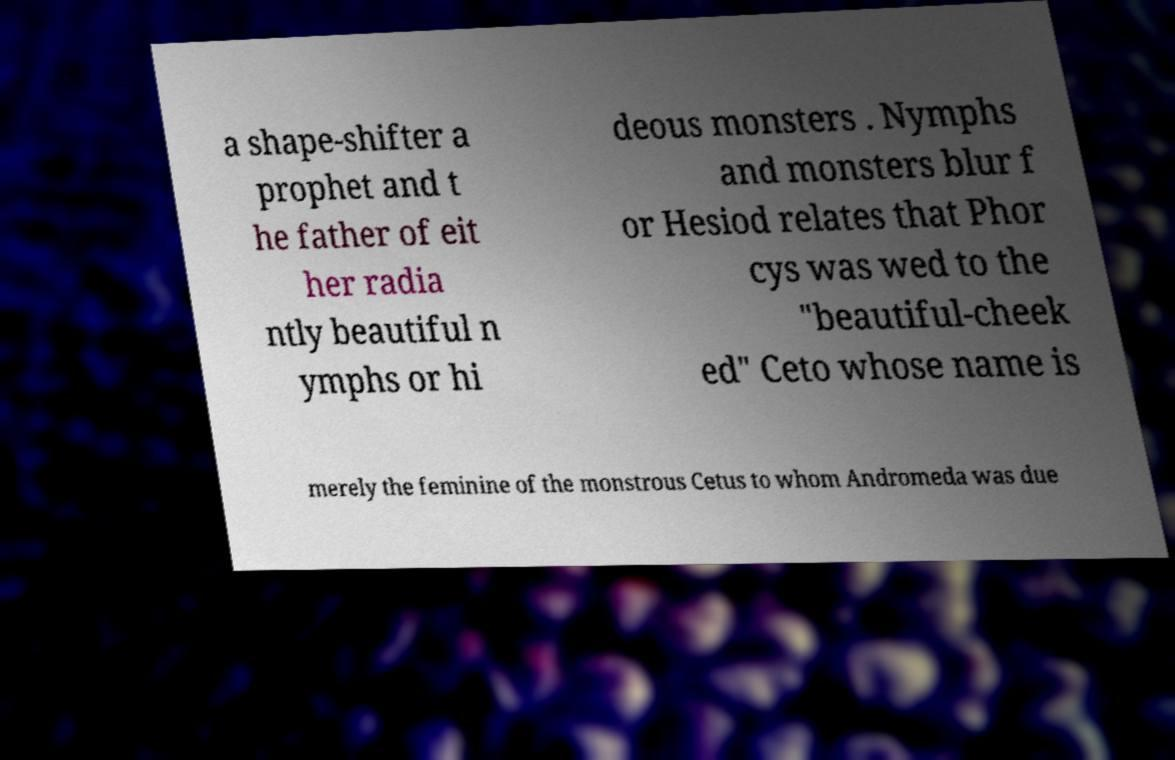I need the written content from this picture converted into text. Can you do that? a shape-shifter a prophet and t he father of eit her radia ntly beautiful n ymphs or hi deous monsters . Nymphs and monsters blur f or Hesiod relates that Phor cys was wed to the "beautiful-cheek ed" Ceto whose name is merely the feminine of the monstrous Cetus to whom Andromeda was due 